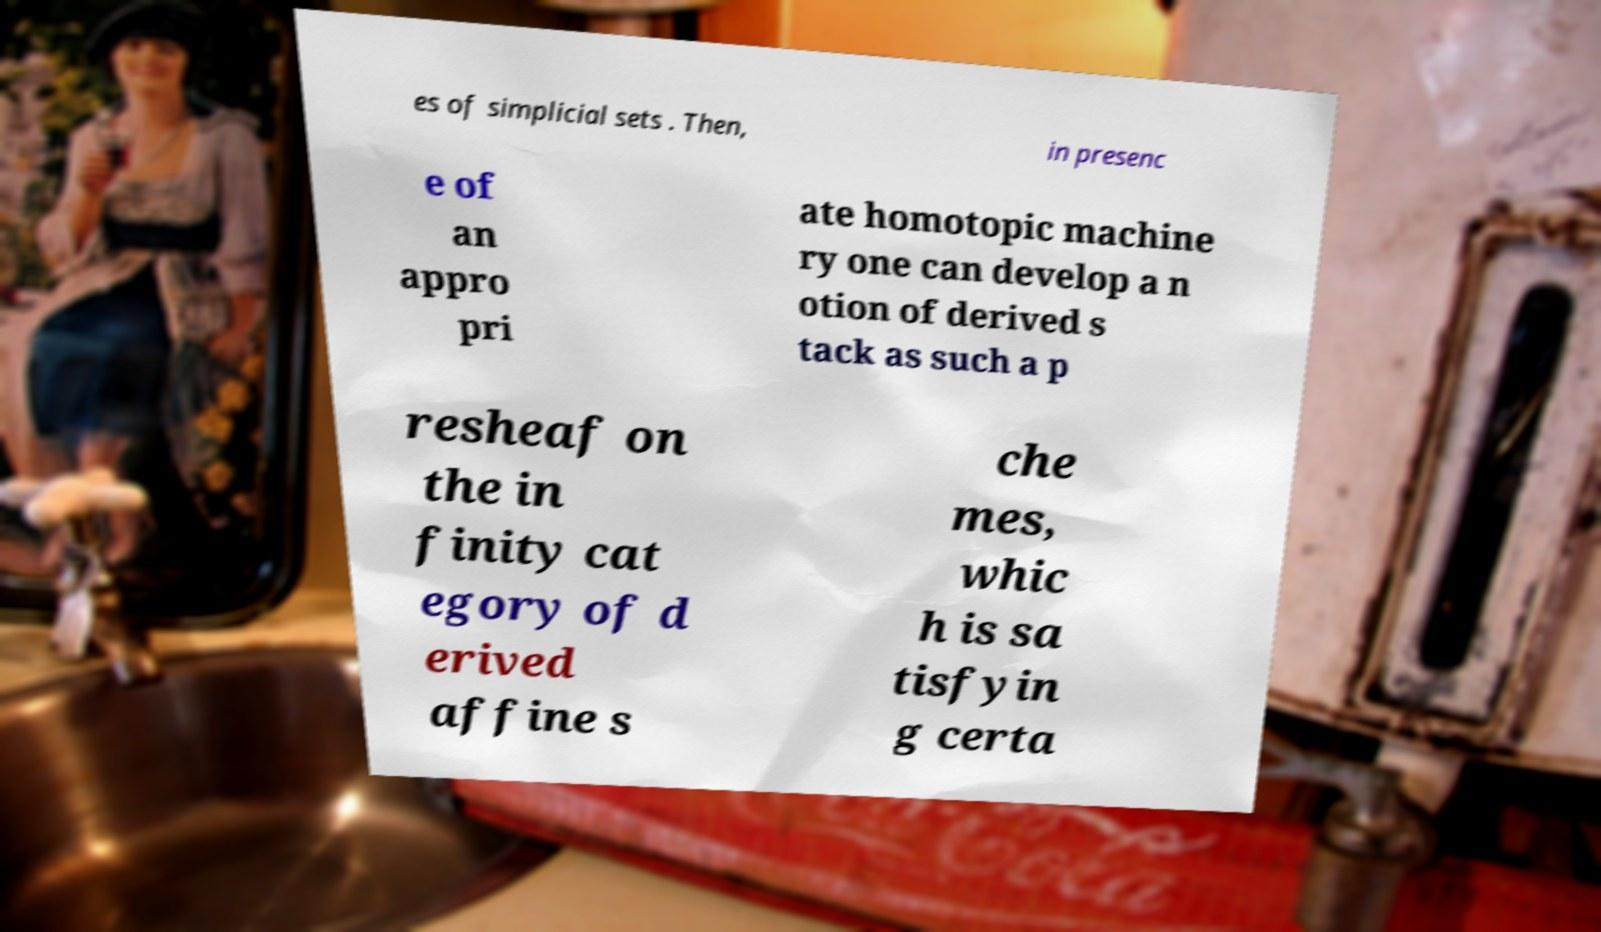Please identify and transcribe the text found in this image. es of simplicial sets . Then, in presenc e of an appro pri ate homotopic machine ry one can develop a n otion of derived s tack as such a p resheaf on the in finity cat egory of d erived affine s che mes, whic h is sa tisfyin g certa 